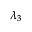<formula> <loc_0><loc_0><loc_500><loc_500>\lambda _ { 3 }</formula> 